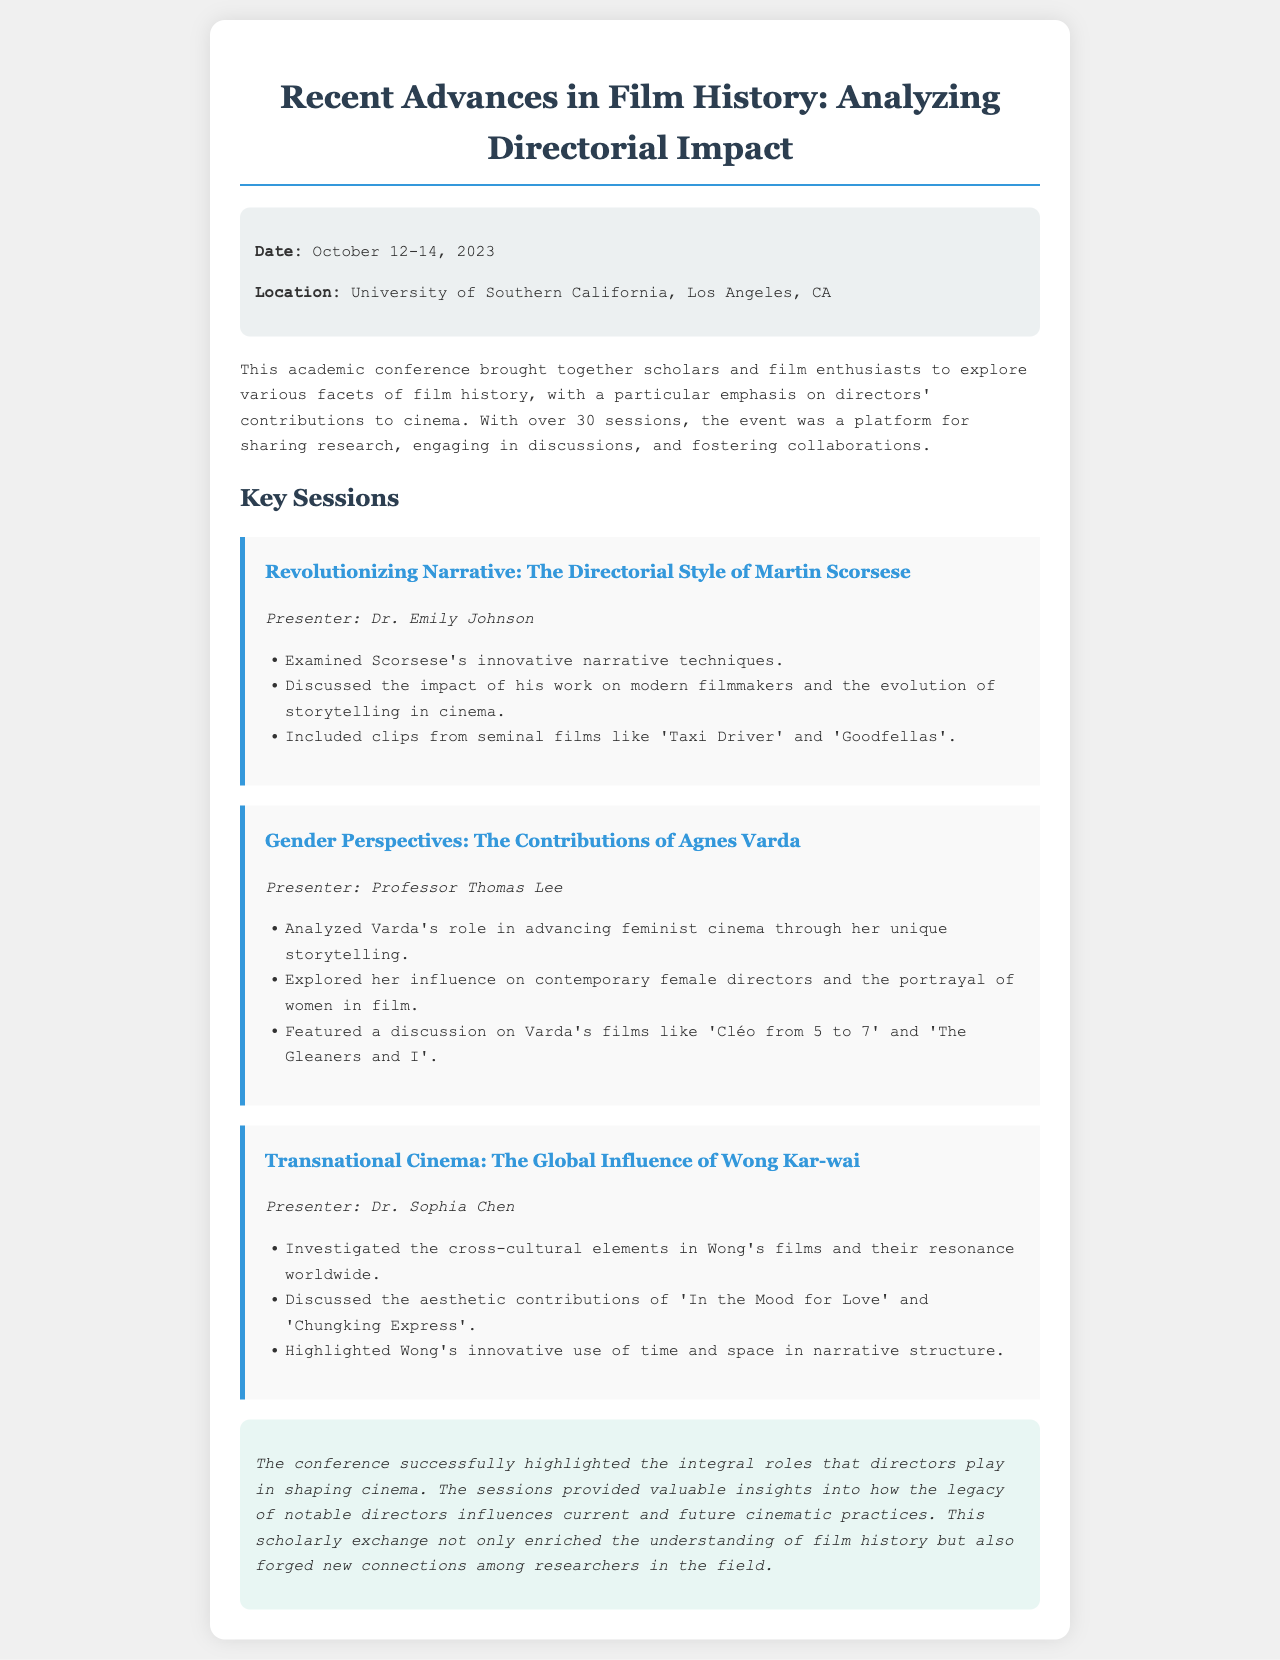What was the date of the conference? The conference took place from October 12-14, 2023, as stated in the conference info section.
Answer: October 12-14, 2023 Where was the conference held? The location of the conference is mentioned as the University of Southern California, Los Angeles, CA.
Answer: University of Southern California, Los Angeles, CA Who presented the session on Agnes Varda? The presenter for the session on Agnes Varda is identified in the session details provided.
Answer: Professor Thomas Lee What was a central theme of the conference? The document highlights an emphasis on directors' contributions to cinema as a main theme of the conference.
Answer: Directors' contributions to cinema Which film was cited in the session about Wong Kar-wai? Specific films are named during the session discussing Wong Kar-wai's influence, one of which is emphasized.
Answer: In the Mood for Love What does the conclusion state about the conference? The conclusion summarizes the overall impact of the conference, including its contribution to film studies.
Answer: Highlighted the integral roles that directors play in shaping cinema 